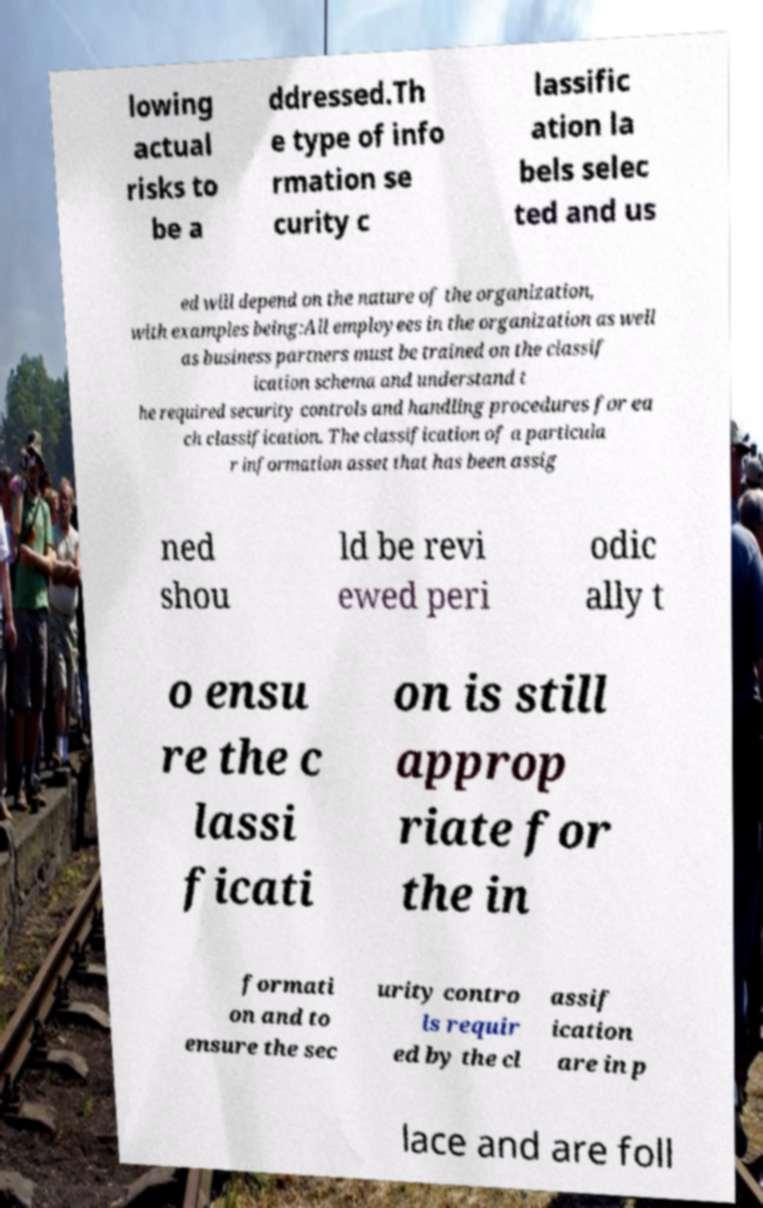For documentation purposes, I need the text within this image transcribed. Could you provide that? lowing actual risks to be a ddressed.Th e type of info rmation se curity c lassific ation la bels selec ted and us ed will depend on the nature of the organization, with examples being:All employees in the organization as well as business partners must be trained on the classif ication schema and understand t he required security controls and handling procedures for ea ch classification. The classification of a particula r information asset that has been assig ned shou ld be revi ewed peri odic ally t o ensu re the c lassi ficati on is still approp riate for the in formati on and to ensure the sec urity contro ls requir ed by the cl assif ication are in p lace and are foll 